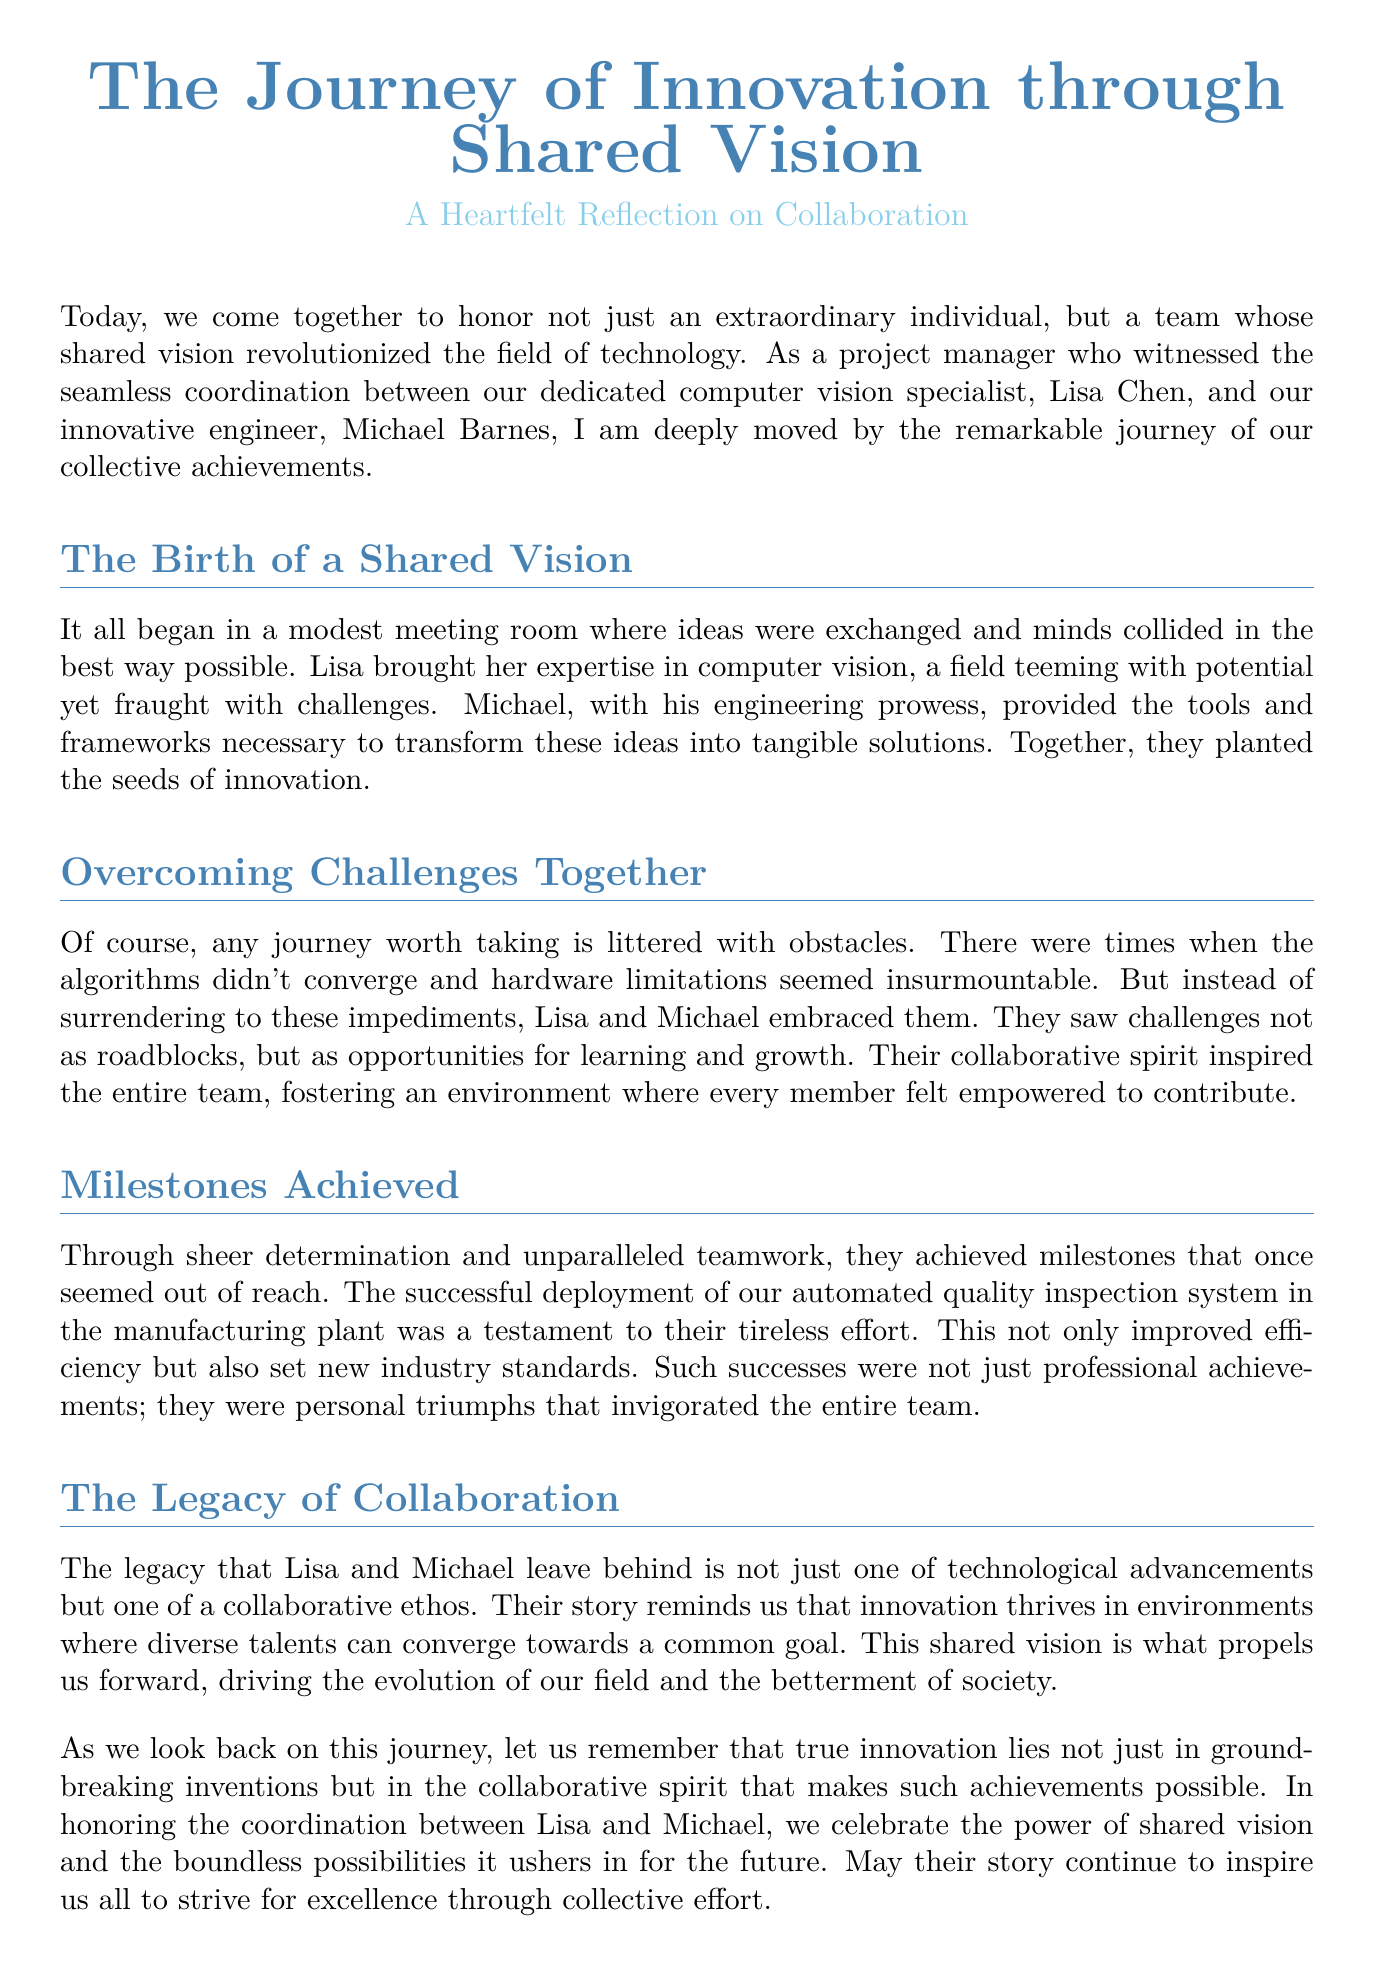What is the title of the document? The title of the document is presented clearly at the beginning, which sets the theme for the reflection.
Answer: The Journey of Innovation through Shared Vision Who are the key individuals mentioned in the eulogy? The eulogy highlights specific individuals whose contributions were significant to the shared vision, namely the computer vision specialist and the engineer.
Answer: Lisa Chen and Michael Barnes What specific system was successfully deployed? The document describes a particular milestone achieved through collaboration, which showcases their joint effort.
Answer: Automated quality inspection system What color is associated with the main title? The document utilizes colors to enhance its visual appeal and to differentiate sections, specifically the main title.
Answer: Maincolor (RGB: 70,130,180) What was the perceived attitude towards challenges? The eulogy conveys a positive mindset towards obstacles faced during the journey, reflecting the collaborative approach taken by the teams involved.
Answer: Opportunities for learning and growth What is highlighted as the legacy left by Lisa and Michael? The eulogy emphasizes key takeaways from their partnership and contributions to the field, reflecting the essence of their teamwork.
Answer: Collaborative ethos What environment is suggested to foster innovation? The document mentions characteristics of the environment that were conducive to creativity and progress, particularly in teamwork settings.
Answer: Where diverse talents can converge towards a common goal What does the eulogy urge the audience to remember about innovation? The conclusion reflects on a broader lesson beyond technological advancements, emphasizing a valuable aspect of the innovation process.
Answer: The collaborative spirit 